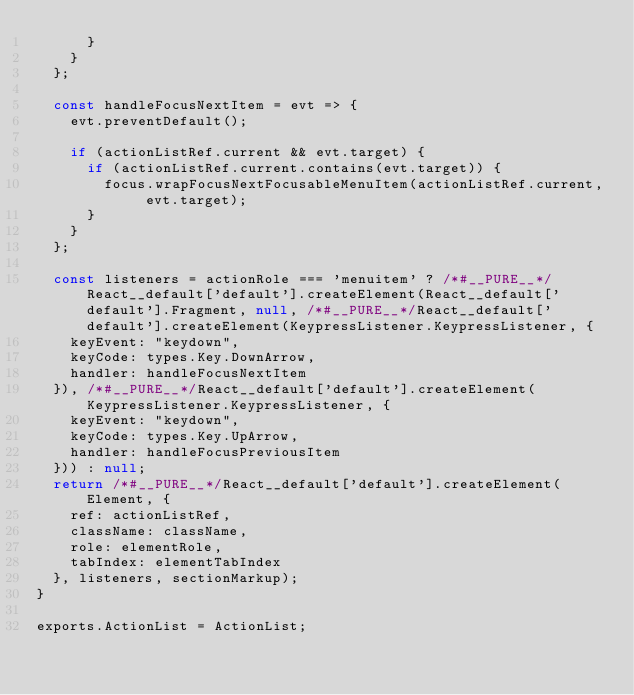Convert code to text. <code><loc_0><loc_0><loc_500><loc_500><_JavaScript_>      }
    }
  };

  const handleFocusNextItem = evt => {
    evt.preventDefault();

    if (actionListRef.current && evt.target) {
      if (actionListRef.current.contains(evt.target)) {
        focus.wrapFocusNextFocusableMenuItem(actionListRef.current, evt.target);
      }
    }
  };

  const listeners = actionRole === 'menuitem' ? /*#__PURE__*/React__default['default'].createElement(React__default['default'].Fragment, null, /*#__PURE__*/React__default['default'].createElement(KeypressListener.KeypressListener, {
    keyEvent: "keydown",
    keyCode: types.Key.DownArrow,
    handler: handleFocusNextItem
  }), /*#__PURE__*/React__default['default'].createElement(KeypressListener.KeypressListener, {
    keyEvent: "keydown",
    keyCode: types.Key.UpArrow,
    handler: handleFocusPreviousItem
  })) : null;
  return /*#__PURE__*/React__default['default'].createElement(Element, {
    ref: actionListRef,
    className: className,
    role: elementRole,
    tabIndex: elementTabIndex
  }, listeners, sectionMarkup);
}

exports.ActionList = ActionList;
</code> 